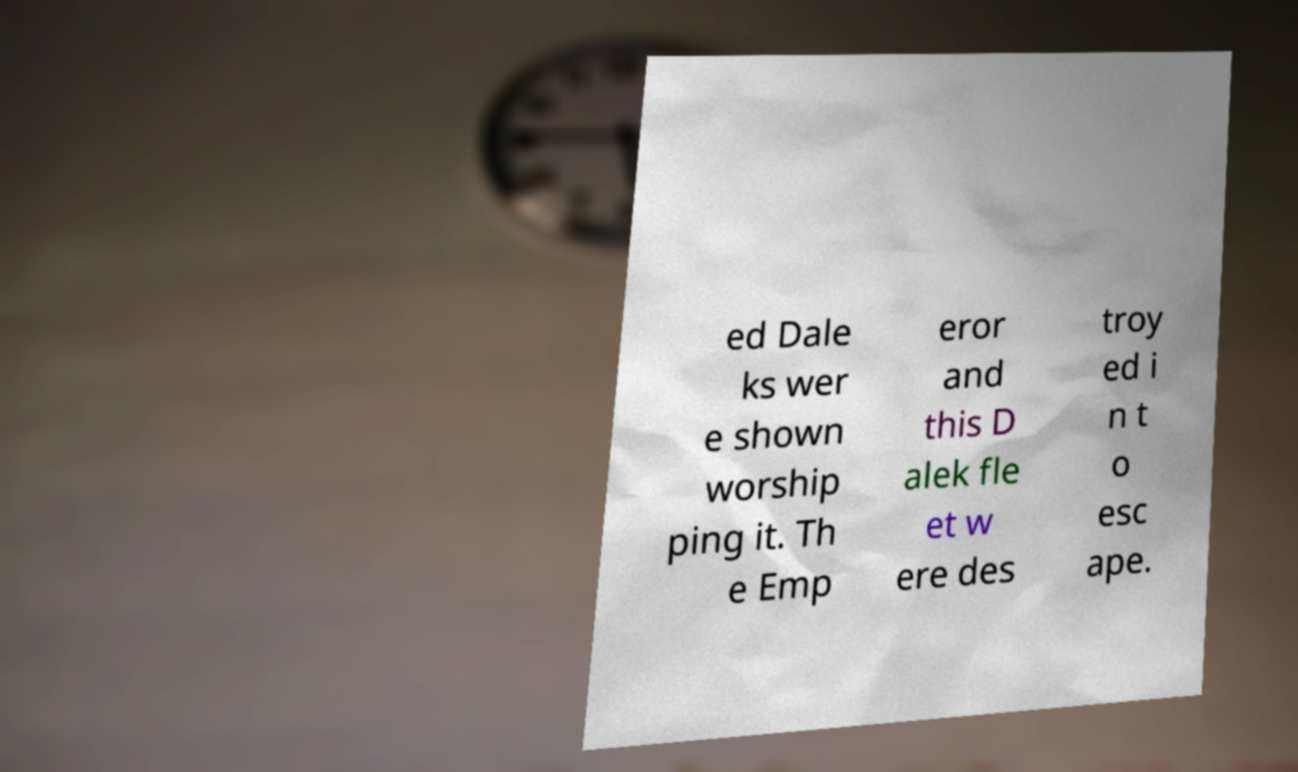Can you accurately transcribe the text from the provided image for me? ed Dale ks wer e shown worship ping it. Th e Emp eror and this D alek fle et w ere des troy ed i n t o esc ape. 